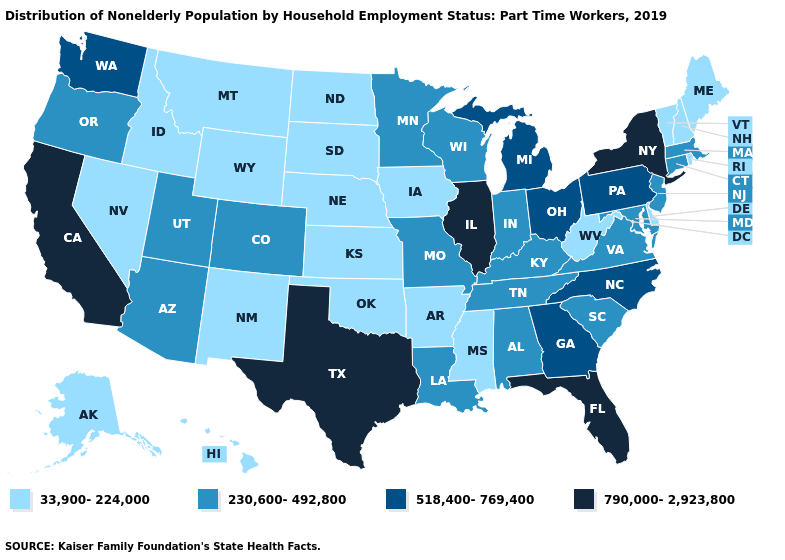Which states have the lowest value in the MidWest?
Short answer required. Iowa, Kansas, Nebraska, North Dakota, South Dakota. Does Minnesota have a lower value than Kansas?
Keep it brief. No. What is the lowest value in the MidWest?
Answer briefly. 33,900-224,000. Does South Dakota have the same value as Arkansas?
Quick response, please. Yes. What is the value of Nevada?
Short answer required. 33,900-224,000. What is the highest value in the West ?
Quick response, please. 790,000-2,923,800. What is the value of Minnesota?
Keep it brief. 230,600-492,800. Is the legend a continuous bar?
Answer briefly. No. Name the states that have a value in the range 230,600-492,800?
Give a very brief answer. Alabama, Arizona, Colorado, Connecticut, Indiana, Kentucky, Louisiana, Maryland, Massachusetts, Minnesota, Missouri, New Jersey, Oregon, South Carolina, Tennessee, Utah, Virginia, Wisconsin. Which states hav the highest value in the MidWest?
Answer briefly. Illinois. Which states hav the highest value in the Northeast?
Write a very short answer. New York. What is the value of Virginia?
Short answer required. 230,600-492,800. What is the highest value in the MidWest ?
Quick response, please. 790,000-2,923,800. Among the states that border Virginia , does Maryland have the highest value?
Short answer required. No. Name the states that have a value in the range 518,400-769,400?
Keep it brief. Georgia, Michigan, North Carolina, Ohio, Pennsylvania, Washington. 